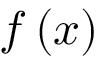<formula> <loc_0><loc_0><loc_500><loc_500>{ f } \left ( x \right )</formula> 